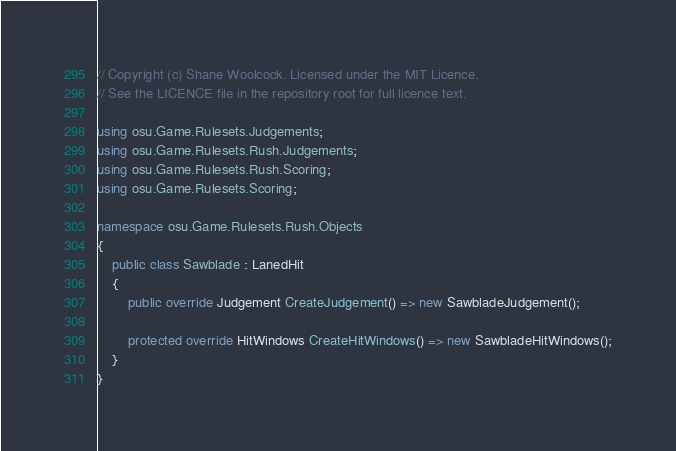Convert code to text. <code><loc_0><loc_0><loc_500><loc_500><_C#_>// Copyright (c) Shane Woolcock. Licensed under the MIT Licence.
// See the LICENCE file in the repository root for full licence text.

using osu.Game.Rulesets.Judgements;
using osu.Game.Rulesets.Rush.Judgements;
using osu.Game.Rulesets.Rush.Scoring;
using osu.Game.Rulesets.Scoring;

namespace osu.Game.Rulesets.Rush.Objects
{
    public class Sawblade : LanedHit
    {
        public override Judgement CreateJudgement() => new SawbladeJudgement();

        protected override HitWindows CreateHitWindows() => new SawbladeHitWindows();
    }
}
</code> 